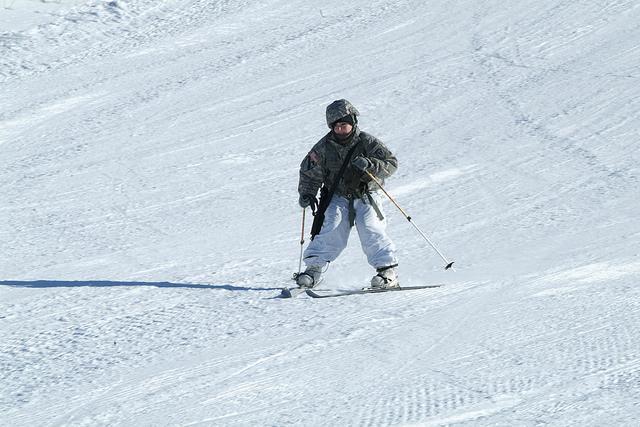How many bikes do you see?
Give a very brief answer. 0. 